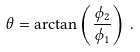<formula> <loc_0><loc_0><loc_500><loc_500>\theta = \arctan \left ( \frac { \phi _ { 2 } } { \phi _ { 1 } } \right ) \, .</formula> 